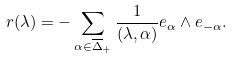<formula> <loc_0><loc_0><loc_500><loc_500>r ( \lambda ) = - \sum _ { \alpha \in \overline { \Delta } _ { + } } \frac { 1 } { ( \lambda , \alpha ) } e _ { \alpha } \wedge e _ { - \alpha } .</formula> 